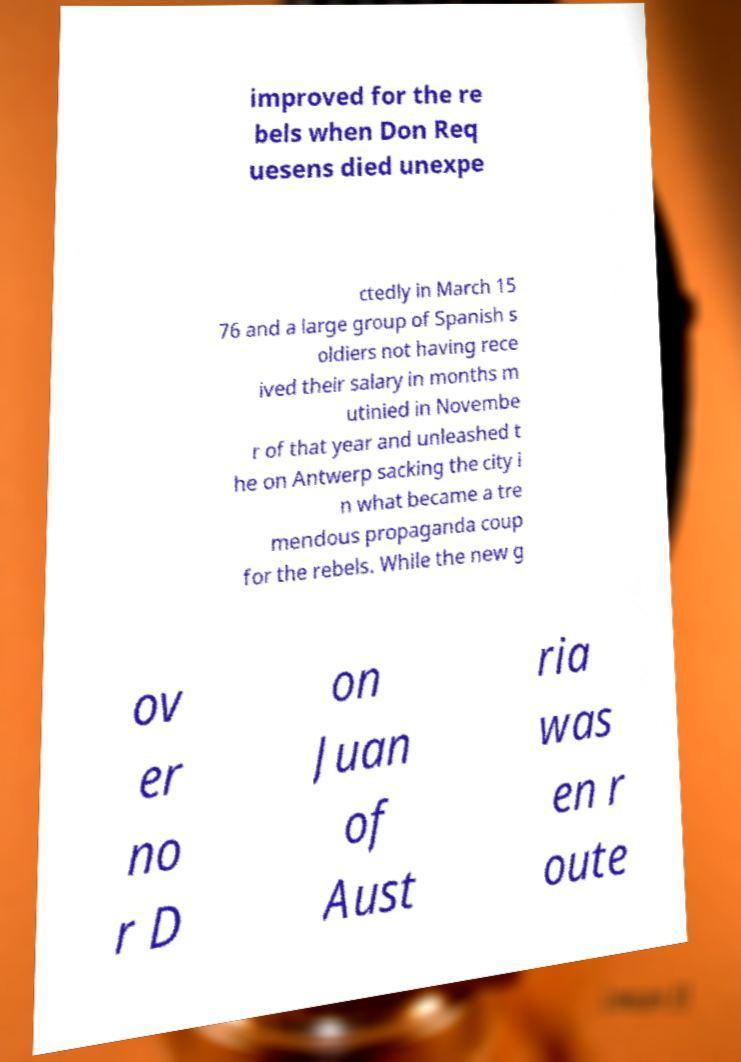Please identify and transcribe the text found in this image. improved for the re bels when Don Req uesens died unexpe ctedly in March 15 76 and a large group of Spanish s oldiers not having rece ived their salary in months m utinied in Novembe r of that year and unleashed t he on Antwerp sacking the city i n what became a tre mendous propaganda coup for the rebels. While the new g ov er no r D on Juan of Aust ria was en r oute 